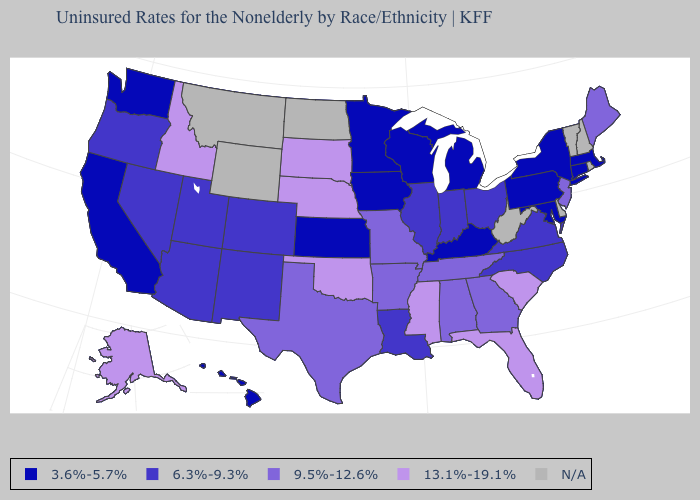Name the states that have a value in the range 3.6%-5.7%?
Give a very brief answer. California, Connecticut, Hawaii, Iowa, Kansas, Kentucky, Maryland, Massachusetts, Michigan, Minnesota, New York, Pennsylvania, Washington, Wisconsin. What is the lowest value in the MidWest?
Keep it brief. 3.6%-5.7%. How many symbols are there in the legend?
Short answer required. 5. Name the states that have a value in the range 13.1%-19.1%?
Concise answer only. Alaska, Florida, Idaho, Mississippi, Nebraska, Oklahoma, South Carolina, South Dakota. Name the states that have a value in the range 13.1%-19.1%?
Short answer required. Alaska, Florida, Idaho, Mississippi, Nebraska, Oklahoma, South Carolina, South Dakota. How many symbols are there in the legend?
Answer briefly. 5. Does Mississippi have the highest value in the USA?
Answer briefly. Yes. Is the legend a continuous bar?
Short answer required. No. Name the states that have a value in the range 13.1%-19.1%?
Keep it brief. Alaska, Florida, Idaho, Mississippi, Nebraska, Oklahoma, South Carolina, South Dakota. Name the states that have a value in the range 6.3%-9.3%?
Keep it brief. Arizona, Colorado, Illinois, Indiana, Louisiana, Nevada, New Mexico, North Carolina, Ohio, Oregon, Utah, Virginia. Name the states that have a value in the range 13.1%-19.1%?
Give a very brief answer. Alaska, Florida, Idaho, Mississippi, Nebraska, Oklahoma, South Carolina, South Dakota. What is the highest value in the USA?
Write a very short answer. 13.1%-19.1%. What is the value of Nevada?
Quick response, please. 6.3%-9.3%. 